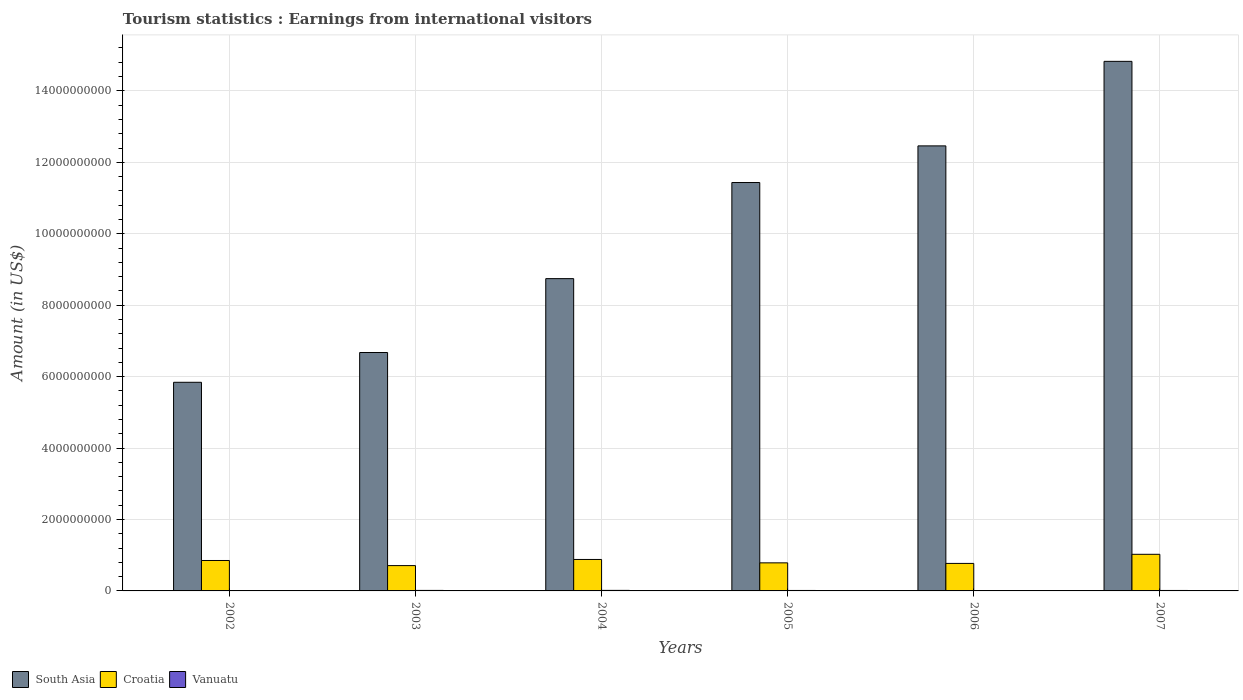How many groups of bars are there?
Offer a terse response. 6. Are the number of bars per tick equal to the number of legend labels?
Make the answer very short. Yes. How many bars are there on the 4th tick from the left?
Offer a terse response. 3. How many bars are there on the 2nd tick from the right?
Make the answer very short. 3. What is the label of the 5th group of bars from the left?
Your answer should be very brief. 2006. In how many cases, is the number of bars for a given year not equal to the number of legend labels?
Offer a very short reply. 0. What is the earnings from international visitors in South Asia in 2004?
Your answer should be compact. 8.74e+09. Across all years, what is the maximum earnings from international visitors in South Asia?
Give a very brief answer. 1.48e+1. Across all years, what is the minimum earnings from international visitors in Croatia?
Make the answer very short. 7.09e+08. In which year was the earnings from international visitors in South Asia minimum?
Your answer should be very brief. 2002. What is the total earnings from international visitors in Vanuatu in the graph?
Make the answer very short. 7.70e+07. What is the difference between the earnings from international visitors in Croatia in 2004 and that in 2006?
Give a very brief answer. 1.11e+08. What is the difference between the earnings from international visitors in Vanuatu in 2003 and the earnings from international visitors in Croatia in 2006?
Your response must be concise. -7.56e+08. What is the average earnings from international visitors in Croatia per year?
Your response must be concise. 8.37e+08. In the year 2004, what is the difference between the earnings from international visitors in Vanuatu and earnings from international visitors in South Asia?
Offer a very short reply. -8.73e+09. What is the ratio of the earnings from international visitors in Croatia in 2002 to that in 2005?
Keep it short and to the point. 1.08. Is the difference between the earnings from international visitors in Vanuatu in 2005 and 2007 greater than the difference between the earnings from international visitors in South Asia in 2005 and 2007?
Provide a succinct answer. Yes. What is the difference between the highest and the second highest earnings from international visitors in Croatia?
Provide a short and direct response. 1.44e+08. What is the difference between the highest and the lowest earnings from international visitors in South Asia?
Offer a very short reply. 8.99e+09. In how many years, is the earnings from international visitors in Vanuatu greater than the average earnings from international visitors in Vanuatu taken over all years?
Keep it short and to the point. 4. What does the 1st bar from the left in 2007 represents?
Ensure brevity in your answer.  South Asia. What does the 1st bar from the right in 2006 represents?
Offer a very short reply. Vanuatu. Is it the case that in every year, the sum of the earnings from international visitors in Vanuatu and earnings from international visitors in South Asia is greater than the earnings from international visitors in Croatia?
Make the answer very short. Yes. Are all the bars in the graph horizontal?
Ensure brevity in your answer.  No. How many years are there in the graph?
Provide a short and direct response. 6. Does the graph contain any zero values?
Offer a very short reply. No. Does the graph contain grids?
Provide a short and direct response. Yes. Where does the legend appear in the graph?
Provide a succinct answer. Bottom left. How many legend labels are there?
Provide a short and direct response. 3. How are the legend labels stacked?
Your response must be concise. Horizontal. What is the title of the graph?
Your answer should be compact. Tourism statistics : Earnings from international visitors. Does "Nigeria" appear as one of the legend labels in the graph?
Your answer should be compact. No. What is the label or title of the X-axis?
Give a very brief answer. Years. What is the label or title of the Y-axis?
Provide a short and direct response. Amount (in US$). What is the Amount (in US$) in South Asia in 2002?
Your answer should be compact. 5.84e+09. What is the Amount (in US$) of Croatia in 2002?
Offer a terse response. 8.52e+08. What is the Amount (in US$) in Vanuatu in 2002?
Keep it short and to the point. 1.10e+07. What is the Amount (in US$) of South Asia in 2003?
Keep it short and to the point. 6.67e+09. What is the Amount (in US$) of Croatia in 2003?
Offer a terse response. 7.09e+08. What is the Amount (in US$) of Vanuatu in 2003?
Offer a very short reply. 1.40e+07. What is the Amount (in US$) of South Asia in 2004?
Offer a very short reply. 8.74e+09. What is the Amount (in US$) of Croatia in 2004?
Offer a very short reply. 8.81e+08. What is the Amount (in US$) in Vanuatu in 2004?
Make the answer very short. 1.50e+07. What is the Amount (in US$) in South Asia in 2005?
Keep it short and to the point. 1.14e+1. What is the Amount (in US$) in Croatia in 2005?
Offer a very short reply. 7.86e+08. What is the Amount (in US$) in Vanuatu in 2005?
Offer a terse response. 1.30e+07. What is the Amount (in US$) in South Asia in 2006?
Offer a terse response. 1.25e+1. What is the Amount (in US$) in Croatia in 2006?
Provide a short and direct response. 7.70e+08. What is the Amount (in US$) of Vanuatu in 2006?
Your answer should be compact. 1.10e+07. What is the Amount (in US$) in South Asia in 2007?
Your answer should be compact. 1.48e+1. What is the Amount (in US$) of Croatia in 2007?
Your answer should be very brief. 1.02e+09. What is the Amount (in US$) in Vanuatu in 2007?
Give a very brief answer. 1.30e+07. Across all years, what is the maximum Amount (in US$) in South Asia?
Make the answer very short. 1.48e+1. Across all years, what is the maximum Amount (in US$) in Croatia?
Give a very brief answer. 1.02e+09. Across all years, what is the maximum Amount (in US$) in Vanuatu?
Your answer should be very brief. 1.50e+07. Across all years, what is the minimum Amount (in US$) in South Asia?
Ensure brevity in your answer.  5.84e+09. Across all years, what is the minimum Amount (in US$) of Croatia?
Your response must be concise. 7.09e+08. Across all years, what is the minimum Amount (in US$) of Vanuatu?
Give a very brief answer. 1.10e+07. What is the total Amount (in US$) in South Asia in the graph?
Keep it short and to the point. 6.00e+1. What is the total Amount (in US$) in Croatia in the graph?
Ensure brevity in your answer.  5.02e+09. What is the total Amount (in US$) of Vanuatu in the graph?
Offer a very short reply. 7.70e+07. What is the difference between the Amount (in US$) of South Asia in 2002 and that in 2003?
Your answer should be very brief. -8.34e+08. What is the difference between the Amount (in US$) of Croatia in 2002 and that in 2003?
Your response must be concise. 1.43e+08. What is the difference between the Amount (in US$) in Vanuatu in 2002 and that in 2003?
Your answer should be very brief. -3.00e+06. What is the difference between the Amount (in US$) of South Asia in 2002 and that in 2004?
Keep it short and to the point. -2.90e+09. What is the difference between the Amount (in US$) in Croatia in 2002 and that in 2004?
Offer a very short reply. -2.90e+07. What is the difference between the Amount (in US$) of South Asia in 2002 and that in 2005?
Ensure brevity in your answer.  -5.59e+09. What is the difference between the Amount (in US$) in Croatia in 2002 and that in 2005?
Make the answer very short. 6.60e+07. What is the difference between the Amount (in US$) in Vanuatu in 2002 and that in 2005?
Offer a very short reply. -2.00e+06. What is the difference between the Amount (in US$) in South Asia in 2002 and that in 2006?
Your answer should be compact. -6.62e+09. What is the difference between the Amount (in US$) in Croatia in 2002 and that in 2006?
Your answer should be compact. 8.20e+07. What is the difference between the Amount (in US$) in South Asia in 2002 and that in 2007?
Keep it short and to the point. -8.99e+09. What is the difference between the Amount (in US$) in Croatia in 2002 and that in 2007?
Provide a succinct answer. -1.73e+08. What is the difference between the Amount (in US$) in South Asia in 2003 and that in 2004?
Your response must be concise. -2.07e+09. What is the difference between the Amount (in US$) of Croatia in 2003 and that in 2004?
Your response must be concise. -1.72e+08. What is the difference between the Amount (in US$) of South Asia in 2003 and that in 2005?
Ensure brevity in your answer.  -4.76e+09. What is the difference between the Amount (in US$) of Croatia in 2003 and that in 2005?
Offer a terse response. -7.70e+07. What is the difference between the Amount (in US$) of Vanuatu in 2003 and that in 2005?
Provide a short and direct response. 1.00e+06. What is the difference between the Amount (in US$) in South Asia in 2003 and that in 2006?
Make the answer very short. -5.78e+09. What is the difference between the Amount (in US$) of Croatia in 2003 and that in 2006?
Keep it short and to the point. -6.10e+07. What is the difference between the Amount (in US$) of Vanuatu in 2003 and that in 2006?
Your answer should be very brief. 3.00e+06. What is the difference between the Amount (in US$) of South Asia in 2003 and that in 2007?
Your response must be concise. -8.15e+09. What is the difference between the Amount (in US$) of Croatia in 2003 and that in 2007?
Your answer should be compact. -3.16e+08. What is the difference between the Amount (in US$) of South Asia in 2004 and that in 2005?
Offer a terse response. -2.69e+09. What is the difference between the Amount (in US$) of Croatia in 2004 and that in 2005?
Offer a terse response. 9.50e+07. What is the difference between the Amount (in US$) in South Asia in 2004 and that in 2006?
Give a very brief answer. -3.72e+09. What is the difference between the Amount (in US$) in Croatia in 2004 and that in 2006?
Make the answer very short. 1.11e+08. What is the difference between the Amount (in US$) in Vanuatu in 2004 and that in 2006?
Make the answer very short. 4.00e+06. What is the difference between the Amount (in US$) of South Asia in 2004 and that in 2007?
Your answer should be very brief. -6.08e+09. What is the difference between the Amount (in US$) in Croatia in 2004 and that in 2007?
Offer a very short reply. -1.44e+08. What is the difference between the Amount (in US$) of South Asia in 2005 and that in 2006?
Provide a succinct answer. -1.03e+09. What is the difference between the Amount (in US$) of Croatia in 2005 and that in 2006?
Offer a very short reply. 1.60e+07. What is the difference between the Amount (in US$) in Vanuatu in 2005 and that in 2006?
Make the answer very short. 2.00e+06. What is the difference between the Amount (in US$) in South Asia in 2005 and that in 2007?
Ensure brevity in your answer.  -3.39e+09. What is the difference between the Amount (in US$) of Croatia in 2005 and that in 2007?
Offer a very short reply. -2.39e+08. What is the difference between the Amount (in US$) of Vanuatu in 2005 and that in 2007?
Give a very brief answer. 0. What is the difference between the Amount (in US$) of South Asia in 2006 and that in 2007?
Offer a very short reply. -2.37e+09. What is the difference between the Amount (in US$) in Croatia in 2006 and that in 2007?
Provide a succinct answer. -2.55e+08. What is the difference between the Amount (in US$) of South Asia in 2002 and the Amount (in US$) of Croatia in 2003?
Give a very brief answer. 5.13e+09. What is the difference between the Amount (in US$) in South Asia in 2002 and the Amount (in US$) in Vanuatu in 2003?
Keep it short and to the point. 5.83e+09. What is the difference between the Amount (in US$) in Croatia in 2002 and the Amount (in US$) in Vanuatu in 2003?
Make the answer very short. 8.38e+08. What is the difference between the Amount (in US$) in South Asia in 2002 and the Amount (in US$) in Croatia in 2004?
Your response must be concise. 4.96e+09. What is the difference between the Amount (in US$) in South Asia in 2002 and the Amount (in US$) in Vanuatu in 2004?
Keep it short and to the point. 5.83e+09. What is the difference between the Amount (in US$) in Croatia in 2002 and the Amount (in US$) in Vanuatu in 2004?
Give a very brief answer. 8.37e+08. What is the difference between the Amount (in US$) in South Asia in 2002 and the Amount (in US$) in Croatia in 2005?
Keep it short and to the point. 5.05e+09. What is the difference between the Amount (in US$) in South Asia in 2002 and the Amount (in US$) in Vanuatu in 2005?
Provide a succinct answer. 5.83e+09. What is the difference between the Amount (in US$) in Croatia in 2002 and the Amount (in US$) in Vanuatu in 2005?
Make the answer very short. 8.39e+08. What is the difference between the Amount (in US$) of South Asia in 2002 and the Amount (in US$) of Croatia in 2006?
Keep it short and to the point. 5.07e+09. What is the difference between the Amount (in US$) in South Asia in 2002 and the Amount (in US$) in Vanuatu in 2006?
Your answer should be very brief. 5.83e+09. What is the difference between the Amount (in US$) in Croatia in 2002 and the Amount (in US$) in Vanuatu in 2006?
Your answer should be very brief. 8.41e+08. What is the difference between the Amount (in US$) in South Asia in 2002 and the Amount (in US$) in Croatia in 2007?
Give a very brief answer. 4.82e+09. What is the difference between the Amount (in US$) of South Asia in 2002 and the Amount (in US$) of Vanuatu in 2007?
Keep it short and to the point. 5.83e+09. What is the difference between the Amount (in US$) of Croatia in 2002 and the Amount (in US$) of Vanuatu in 2007?
Give a very brief answer. 8.39e+08. What is the difference between the Amount (in US$) in South Asia in 2003 and the Amount (in US$) in Croatia in 2004?
Your response must be concise. 5.79e+09. What is the difference between the Amount (in US$) in South Asia in 2003 and the Amount (in US$) in Vanuatu in 2004?
Your answer should be compact. 6.66e+09. What is the difference between the Amount (in US$) of Croatia in 2003 and the Amount (in US$) of Vanuatu in 2004?
Offer a terse response. 6.94e+08. What is the difference between the Amount (in US$) in South Asia in 2003 and the Amount (in US$) in Croatia in 2005?
Offer a terse response. 5.89e+09. What is the difference between the Amount (in US$) of South Asia in 2003 and the Amount (in US$) of Vanuatu in 2005?
Keep it short and to the point. 6.66e+09. What is the difference between the Amount (in US$) in Croatia in 2003 and the Amount (in US$) in Vanuatu in 2005?
Your response must be concise. 6.96e+08. What is the difference between the Amount (in US$) of South Asia in 2003 and the Amount (in US$) of Croatia in 2006?
Make the answer very short. 5.90e+09. What is the difference between the Amount (in US$) in South Asia in 2003 and the Amount (in US$) in Vanuatu in 2006?
Your response must be concise. 6.66e+09. What is the difference between the Amount (in US$) of Croatia in 2003 and the Amount (in US$) of Vanuatu in 2006?
Give a very brief answer. 6.98e+08. What is the difference between the Amount (in US$) of South Asia in 2003 and the Amount (in US$) of Croatia in 2007?
Keep it short and to the point. 5.65e+09. What is the difference between the Amount (in US$) of South Asia in 2003 and the Amount (in US$) of Vanuatu in 2007?
Offer a very short reply. 6.66e+09. What is the difference between the Amount (in US$) in Croatia in 2003 and the Amount (in US$) in Vanuatu in 2007?
Provide a succinct answer. 6.96e+08. What is the difference between the Amount (in US$) of South Asia in 2004 and the Amount (in US$) of Croatia in 2005?
Your answer should be compact. 7.96e+09. What is the difference between the Amount (in US$) of South Asia in 2004 and the Amount (in US$) of Vanuatu in 2005?
Your answer should be very brief. 8.73e+09. What is the difference between the Amount (in US$) of Croatia in 2004 and the Amount (in US$) of Vanuatu in 2005?
Your answer should be very brief. 8.68e+08. What is the difference between the Amount (in US$) in South Asia in 2004 and the Amount (in US$) in Croatia in 2006?
Offer a terse response. 7.97e+09. What is the difference between the Amount (in US$) in South Asia in 2004 and the Amount (in US$) in Vanuatu in 2006?
Provide a succinct answer. 8.73e+09. What is the difference between the Amount (in US$) of Croatia in 2004 and the Amount (in US$) of Vanuatu in 2006?
Provide a short and direct response. 8.70e+08. What is the difference between the Amount (in US$) in South Asia in 2004 and the Amount (in US$) in Croatia in 2007?
Your response must be concise. 7.72e+09. What is the difference between the Amount (in US$) in South Asia in 2004 and the Amount (in US$) in Vanuatu in 2007?
Provide a succinct answer. 8.73e+09. What is the difference between the Amount (in US$) in Croatia in 2004 and the Amount (in US$) in Vanuatu in 2007?
Make the answer very short. 8.68e+08. What is the difference between the Amount (in US$) of South Asia in 2005 and the Amount (in US$) of Croatia in 2006?
Provide a succinct answer. 1.07e+1. What is the difference between the Amount (in US$) of South Asia in 2005 and the Amount (in US$) of Vanuatu in 2006?
Ensure brevity in your answer.  1.14e+1. What is the difference between the Amount (in US$) in Croatia in 2005 and the Amount (in US$) in Vanuatu in 2006?
Provide a short and direct response. 7.75e+08. What is the difference between the Amount (in US$) of South Asia in 2005 and the Amount (in US$) of Croatia in 2007?
Provide a succinct answer. 1.04e+1. What is the difference between the Amount (in US$) of South Asia in 2005 and the Amount (in US$) of Vanuatu in 2007?
Offer a terse response. 1.14e+1. What is the difference between the Amount (in US$) of Croatia in 2005 and the Amount (in US$) of Vanuatu in 2007?
Your answer should be compact. 7.73e+08. What is the difference between the Amount (in US$) in South Asia in 2006 and the Amount (in US$) in Croatia in 2007?
Provide a succinct answer. 1.14e+1. What is the difference between the Amount (in US$) of South Asia in 2006 and the Amount (in US$) of Vanuatu in 2007?
Your response must be concise. 1.24e+1. What is the difference between the Amount (in US$) of Croatia in 2006 and the Amount (in US$) of Vanuatu in 2007?
Your answer should be compact. 7.57e+08. What is the average Amount (in US$) in South Asia per year?
Your answer should be very brief. 1.00e+1. What is the average Amount (in US$) of Croatia per year?
Your answer should be very brief. 8.37e+08. What is the average Amount (in US$) in Vanuatu per year?
Your answer should be compact. 1.28e+07. In the year 2002, what is the difference between the Amount (in US$) in South Asia and Amount (in US$) in Croatia?
Your response must be concise. 4.99e+09. In the year 2002, what is the difference between the Amount (in US$) in South Asia and Amount (in US$) in Vanuatu?
Provide a succinct answer. 5.83e+09. In the year 2002, what is the difference between the Amount (in US$) in Croatia and Amount (in US$) in Vanuatu?
Make the answer very short. 8.41e+08. In the year 2003, what is the difference between the Amount (in US$) in South Asia and Amount (in US$) in Croatia?
Your answer should be compact. 5.97e+09. In the year 2003, what is the difference between the Amount (in US$) of South Asia and Amount (in US$) of Vanuatu?
Make the answer very short. 6.66e+09. In the year 2003, what is the difference between the Amount (in US$) of Croatia and Amount (in US$) of Vanuatu?
Your response must be concise. 6.95e+08. In the year 2004, what is the difference between the Amount (in US$) in South Asia and Amount (in US$) in Croatia?
Give a very brief answer. 7.86e+09. In the year 2004, what is the difference between the Amount (in US$) of South Asia and Amount (in US$) of Vanuatu?
Provide a succinct answer. 8.73e+09. In the year 2004, what is the difference between the Amount (in US$) in Croatia and Amount (in US$) in Vanuatu?
Ensure brevity in your answer.  8.66e+08. In the year 2005, what is the difference between the Amount (in US$) of South Asia and Amount (in US$) of Croatia?
Your response must be concise. 1.06e+1. In the year 2005, what is the difference between the Amount (in US$) of South Asia and Amount (in US$) of Vanuatu?
Your answer should be compact. 1.14e+1. In the year 2005, what is the difference between the Amount (in US$) in Croatia and Amount (in US$) in Vanuatu?
Offer a terse response. 7.73e+08. In the year 2006, what is the difference between the Amount (in US$) in South Asia and Amount (in US$) in Croatia?
Give a very brief answer. 1.17e+1. In the year 2006, what is the difference between the Amount (in US$) in South Asia and Amount (in US$) in Vanuatu?
Ensure brevity in your answer.  1.24e+1. In the year 2006, what is the difference between the Amount (in US$) of Croatia and Amount (in US$) of Vanuatu?
Your answer should be very brief. 7.59e+08. In the year 2007, what is the difference between the Amount (in US$) of South Asia and Amount (in US$) of Croatia?
Provide a succinct answer. 1.38e+1. In the year 2007, what is the difference between the Amount (in US$) in South Asia and Amount (in US$) in Vanuatu?
Your answer should be very brief. 1.48e+1. In the year 2007, what is the difference between the Amount (in US$) in Croatia and Amount (in US$) in Vanuatu?
Provide a short and direct response. 1.01e+09. What is the ratio of the Amount (in US$) of Croatia in 2002 to that in 2003?
Ensure brevity in your answer.  1.2. What is the ratio of the Amount (in US$) in Vanuatu in 2002 to that in 2003?
Offer a terse response. 0.79. What is the ratio of the Amount (in US$) in South Asia in 2002 to that in 2004?
Make the answer very short. 0.67. What is the ratio of the Amount (in US$) in Croatia in 2002 to that in 2004?
Keep it short and to the point. 0.97. What is the ratio of the Amount (in US$) in Vanuatu in 2002 to that in 2004?
Provide a short and direct response. 0.73. What is the ratio of the Amount (in US$) of South Asia in 2002 to that in 2005?
Ensure brevity in your answer.  0.51. What is the ratio of the Amount (in US$) in Croatia in 2002 to that in 2005?
Offer a very short reply. 1.08. What is the ratio of the Amount (in US$) of Vanuatu in 2002 to that in 2005?
Give a very brief answer. 0.85. What is the ratio of the Amount (in US$) in South Asia in 2002 to that in 2006?
Make the answer very short. 0.47. What is the ratio of the Amount (in US$) in Croatia in 2002 to that in 2006?
Ensure brevity in your answer.  1.11. What is the ratio of the Amount (in US$) of Vanuatu in 2002 to that in 2006?
Your response must be concise. 1. What is the ratio of the Amount (in US$) in South Asia in 2002 to that in 2007?
Your answer should be compact. 0.39. What is the ratio of the Amount (in US$) of Croatia in 2002 to that in 2007?
Provide a short and direct response. 0.83. What is the ratio of the Amount (in US$) in Vanuatu in 2002 to that in 2007?
Your answer should be very brief. 0.85. What is the ratio of the Amount (in US$) of South Asia in 2003 to that in 2004?
Offer a very short reply. 0.76. What is the ratio of the Amount (in US$) in Croatia in 2003 to that in 2004?
Make the answer very short. 0.8. What is the ratio of the Amount (in US$) in Vanuatu in 2003 to that in 2004?
Your response must be concise. 0.93. What is the ratio of the Amount (in US$) of South Asia in 2003 to that in 2005?
Provide a short and direct response. 0.58. What is the ratio of the Amount (in US$) in Croatia in 2003 to that in 2005?
Your answer should be compact. 0.9. What is the ratio of the Amount (in US$) of South Asia in 2003 to that in 2006?
Provide a succinct answer. 0.54. What is the ratio of the Amount (in US$) of Croatia in 2003 to that in 2006?
Offer a very short reply. 0.92. What is the ratio of the Amount (in US$) in Vanuatu in 2003 to that in 2006?
Your answer should be compact. 1.27. What is the ratio of the Amount (in US$) in South Asia in 2003 to that in 2007?
Your answer should be very brief. 0.45. What is the ratio of the Amount (in US$) of Croatia in 2003 to that in 2007?
Your answer should be compact. 0.69. What is the ratio of the Amount (in US$) in Vanuatu in 2003 to that in 2007?
Provide a succinct answer. 1.08. What is the ratio of the Amount (in US$) in South Asia in 2004 to that in 2005?
Give a very brief answer. 0.76. What is the ratio of the Amount (in US$) of Croatia in 2004 to that in 2005?
Offer a terse response. 1.12. What is the ratio of the Amount (in US$) of Vanuatu in 2004 to that in 2005?
Your answer should be very brief. 1.15. What is the ratio of the Amount (in US$) in South Asia in 2004 to that in 2006?
Provide a short and direct response. 0.7. What is the ratio of the Amount (in US$) in Croatia in 2004 to that in 2006?
Give a very brief answer. 1.14. What is the ratio of the Amount (in US$) of Vanuatu in 2004 to that in 2006?
Provide a short and direct response. 1.36. What is the ratio of the Amount (in US$) of South Asia in 2004 to that in 2007?
Keep it short and to the point. 0.59. What is the ratio of the Amount (in US$) in Croatia in 2004 to that in 2007?
Your answer should be compact. 0.86. What is the ratio of the Amount (in US$) in Vanuatu in 2004 to that in 2007?
Provide a short and direct response. 1.15. What is the ratio of the Amount (in US$) in South Asia in 2005 to that in 2006?
Offer a very short reply. 0.92. What is the ratio of the Amount (in US$) in Croatia in 2005 to that in 2006?
Offer a very short reply. 1.02. What is the ratio of the Amount (in US$) in Vanuatu in 2005 to that in 2006?
Offer a terse response. 1.18. What is the ratio of the Amount (in US$) in South Asia in 2005 to that in 2007?
Keep it short and to the point. 0.77. What is the ratio of the Amount (in US$) in Croatia in 2005 to that in 2007?
Ensure brevity in your answer.  0.77. What is the ratio of the Amount (in US$) of Vanuatu in 2005 to that in 2007?
Offer a very short reply. 1. What is the ratio of the Amount (in US$) of South Asia in 2006 to that in 2007?
Ensure brevity in your answer.  0.84. What is the ratio of the Amount (in US$) of Croatia in 2006 to that in 2007?
Offer a very short reply. 0.75. What is the ratio of the Amount (in US$) of Vanuatu in 2006 to that in 2007?
Your response must be concise. 0.85. What is the difference between the highest and the second highest Amount (in US$) of South Asia?
Offer a terse response. 2.37e+09. What is the difference between the highest and the second highest Amount (in US$) of Croatia?
Provide a succinct answer. 1.44e+08. What is the difference between the highest and the lowest Amount (in US$) in South Asia?
Provide a succinct answer. 8.99e+09. What is the difference between the highest and the lowest Amount (in US$) of Croatia?
Provide a succinct answer. 3.16e+08. What is the difference between the highest and the lowest Amount (in US$) in Vanuatu?
Make the answer very short. 4.00e+06. 